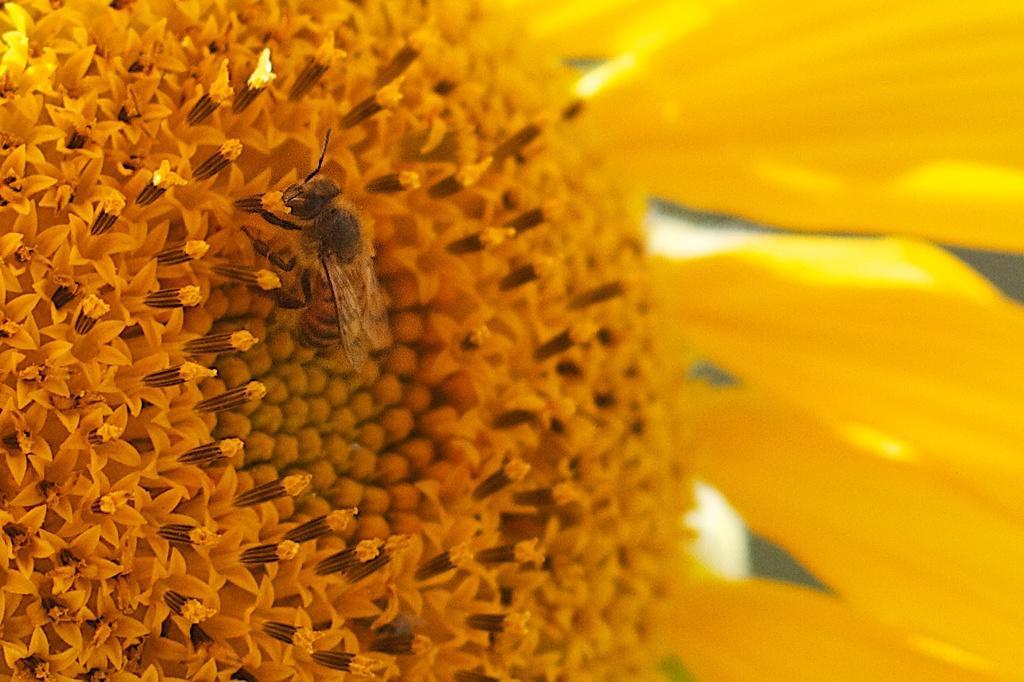Describe this image in one or two sentences. On the left side, there is an insect, having wings and legs standing on the surface of a yellow color flower, which is having yellow color petals. 